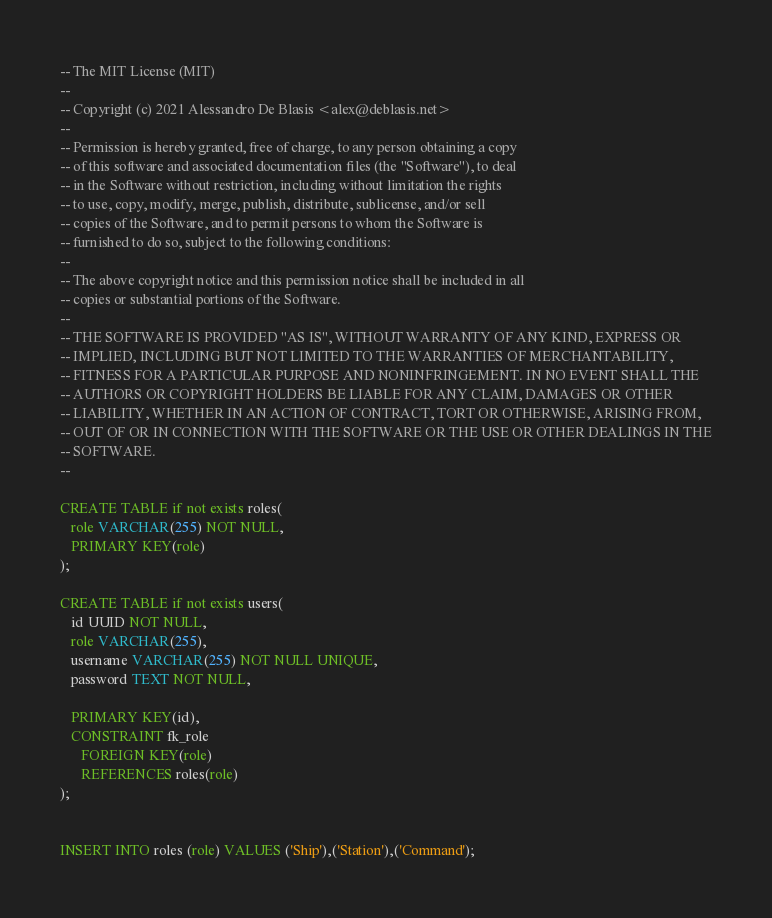Convert code to text. <code><loc_0><loc_0><loc_500><loc_500><_SQL_>-- The MIT License (MIT)
--
-- Copyright (c) 2021 Alessandro De Blasis <alex@deblasis.net>  
--
-- Permission is hereby granted, free of charge, to any person obtaining a copy
-- of this software and associated documentation files (the "Software"), to deal
-- in the Software without restriction, including without limitation the rights
-- to use, copy, modify, merge, publish, distribute, sublicense, and/or sell
-- copies of the Software, and to permit persons to whom the Software is
-- furnished to do so, subject to the following conditions:
--
-- The above copyright notice and this permission notice shall be included in all
-- copies or substantial portions of the Software.
--
-- THE SOFTWARE IS PROVIDED "AS IS", WITHOUT WARRANTY OF ANY KIND, EXPRESS OR
-- IMPLIED, INCLUDING BUT NOT LIMITED TO THE WARRANTIES OF MERCHANTABILITY,
-- FITNESS FOR A PARTICULAR PURPOSE AND NONINFRINGEMENT. IN NO EVENT SHALL THE
-- AUTHORS OR COPYRIGHT HOLDERS BE LIABLE FOR ANY CLAIM, DAMAGES OR OTHER
-- LIABILITY, WHETHER IN AN ACTION OF CONTRACT, TORT OR OTHERWISE, ARISING FROM,
-- OUT OF OR IN CONNECTION WITH THE SOFTWARE OR THE USE OR OTHER DEALINGS IN THE
-- SOFTWARE. 
--

CREATE TABLE if not exists roles(
   role VARCHAR(255) NOT NULL,
   PRIMARY KEY(role)
);

CREATE TABLE if not exists users(
   id UUID NOT NULL,
   role VARCHAR(255),
   username VARCHAR(255) NOT NULL UNIQUE,
   password TEXT NOT NULL,
 
   PRIMARY KEY(id),
   CONSTRAINT fk_role
      FOREIGN KEY(role) 
	  REFERENCES roles(role)
);


INSERT INTO roles (role) VALUES ('Ship'),('Station'),('Command');</code> 